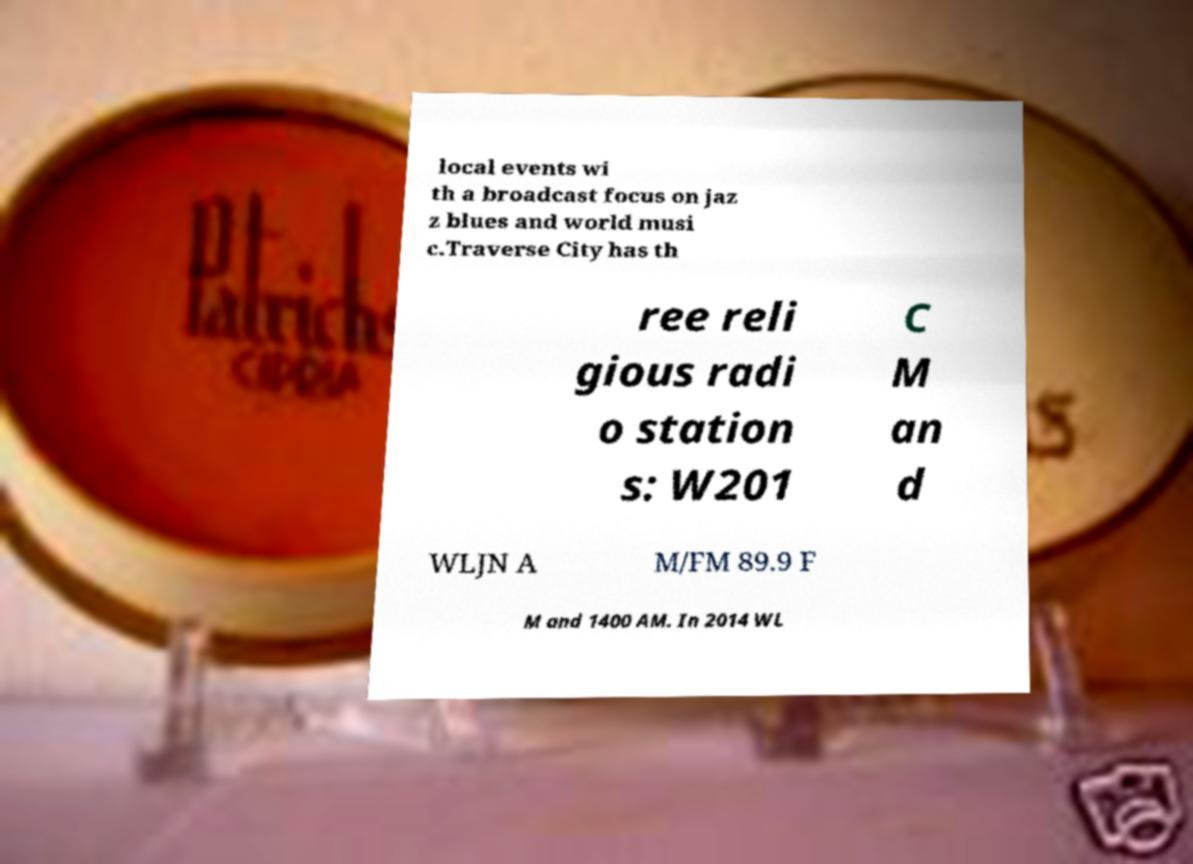Could you extract and type out the text from this image? local events wi th a broadcast focus on jaz z blues and world musi c.Traverse City has th ree reli gious radi o station s: W201 C M an d WLJN A M/FM 89.9 F M and 1400 AM. In 2014 WL 